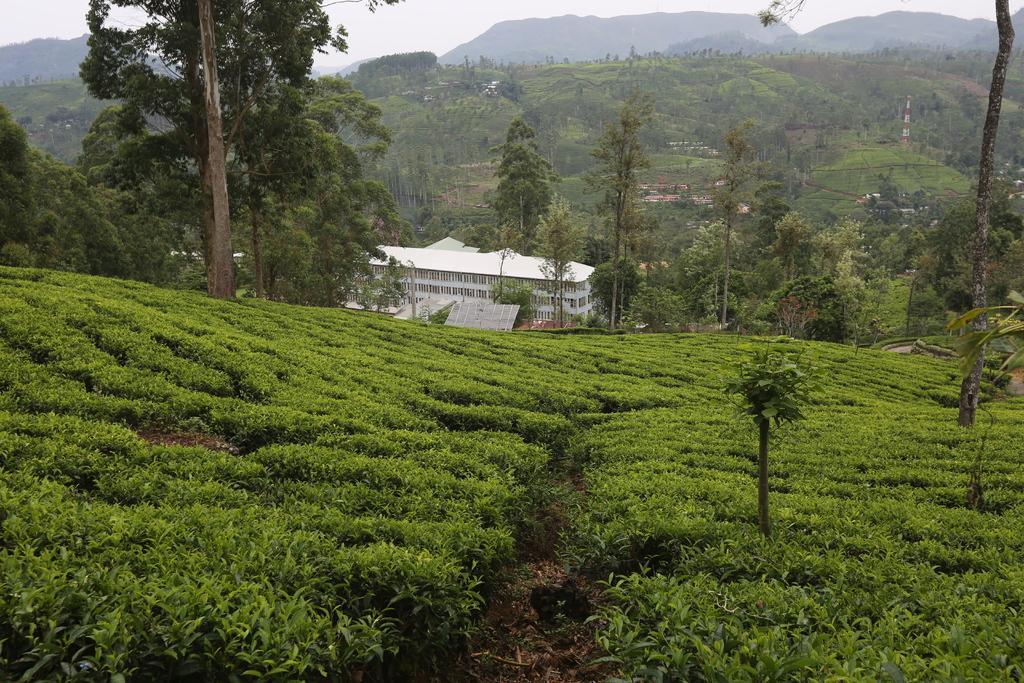Can you describe this image briefly? This picture shows a house and we see trees and hills and a cloudy sky. 